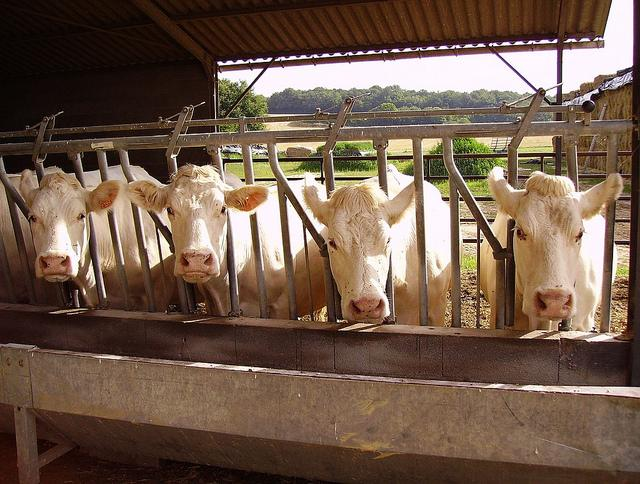Why are these cows held in place at the feeder? Please explain your reasoning. milk. The feeder keeps the cows still so they can be harvested. 